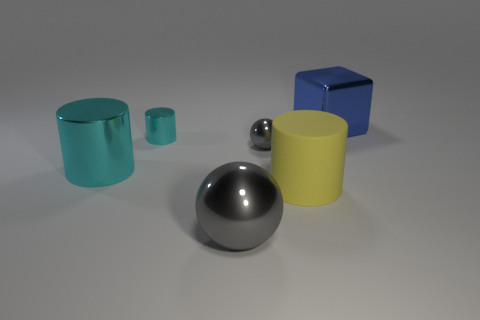Is there any other thing that is the same material as the big yellow thing?
Your answer should be compact. No. What is the size of the yellow thing in front of the gray ball that is behind the big matte cylinder?
Your answer should be compact. Large. Is the number of gray metallic things in front of the big cyan object the same as the number of large rubber things that are in front of the large rubber object?
Keep it short and to the point. No. There is a thing that is in front of the large metallic cylinder and behind the large gray thing; what material is it?
Give a very brief answer. Rubber. Do the yellow cylinder and the gray sphere behind the big metallic ball have the same size?
Ensure brevity in your answer.  No. How many other objects are there of the same color as the small cylinder?
Your response must be concise. 1. Is the number of metallic balls that are behind the big gray thing greater than the number of large purple rubber things?
Your answer should be very brief. Yes. What is the color of the tiny thing that is left of the gray metal sphere in front of the ball behind the big gray metal thing?
Give a very brief answer. Cyan. Is the material of the big cyan cylinder the same as the small cylinder?
Provide a short and direct response. Yes. Are there any gray objects of the same size as the yellow rubber object?
Keep it short and to the point. Yes. 